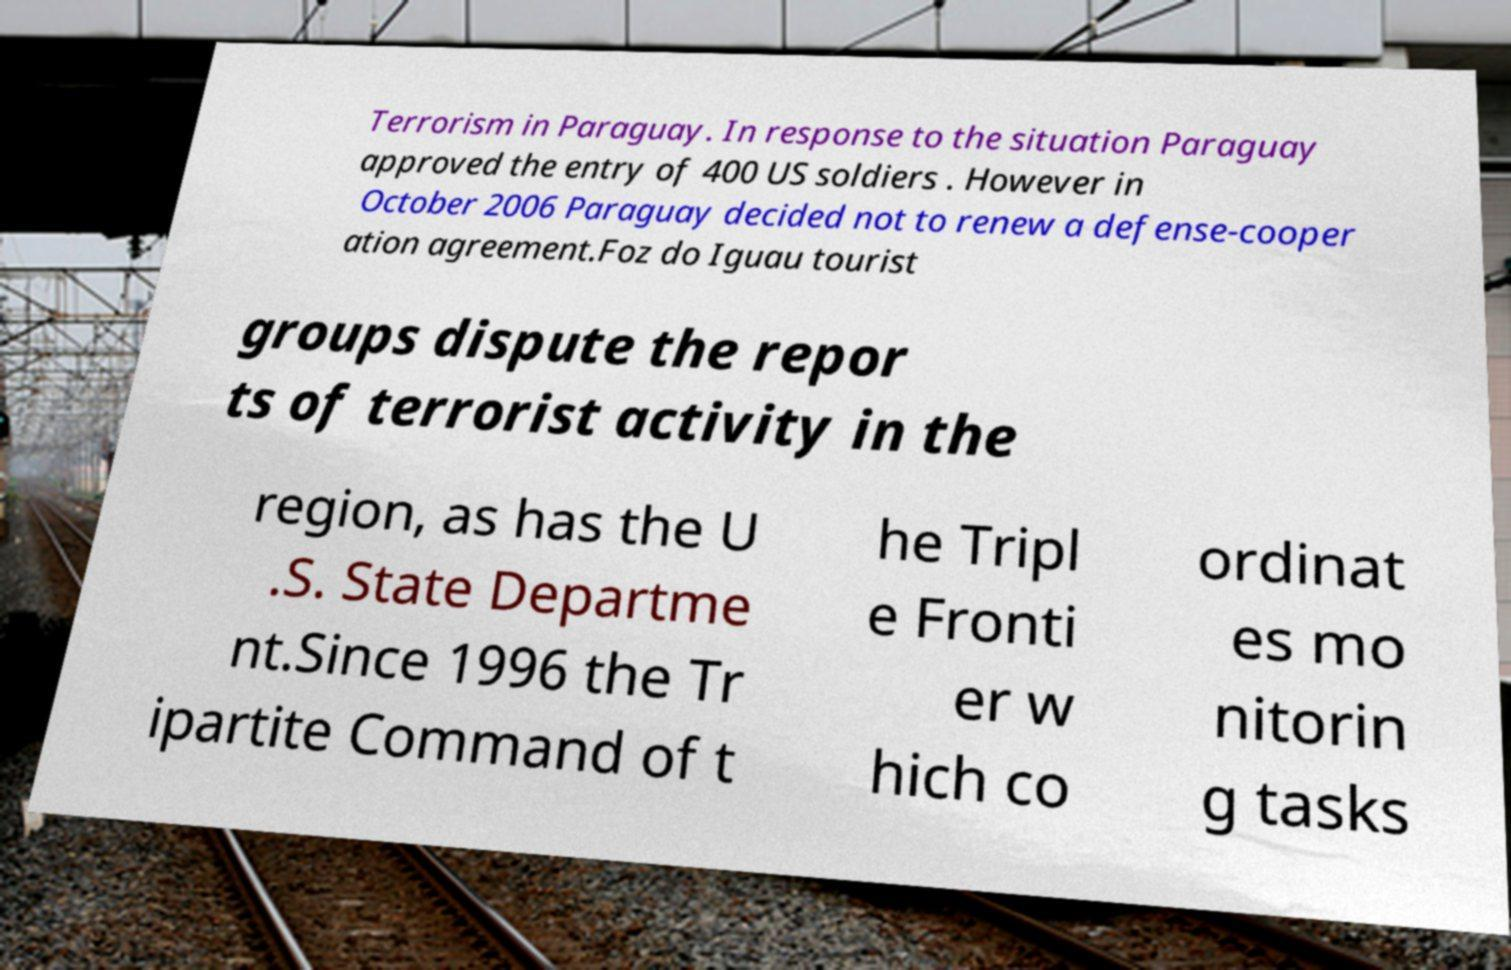I need the written content from this picture converted into text. Can you do that? Terrorism in Paraguay. In response to the situation Paraguay approved the entry of 400 US soldiers . However in October 2006 Paraguay decided not to renew a defense-cooper ation agreement.Foz do Iguau tourist groups dispute the repor ts of terrorist activity in the region, as has the U .S. State Departme nt.Since 1996 the Tr ipartite Command of t he Tripl e Fronti er w hich co ordinat es mo nitorin g tasks 